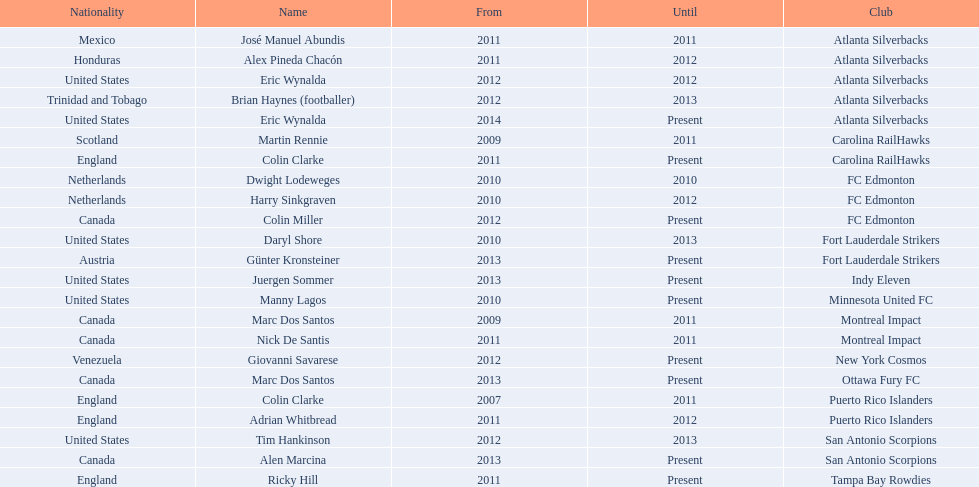What year did marc dos santos start as coach? 2009. Besides marc dos santos, what other coach started in 2009? Martin Rennie. 